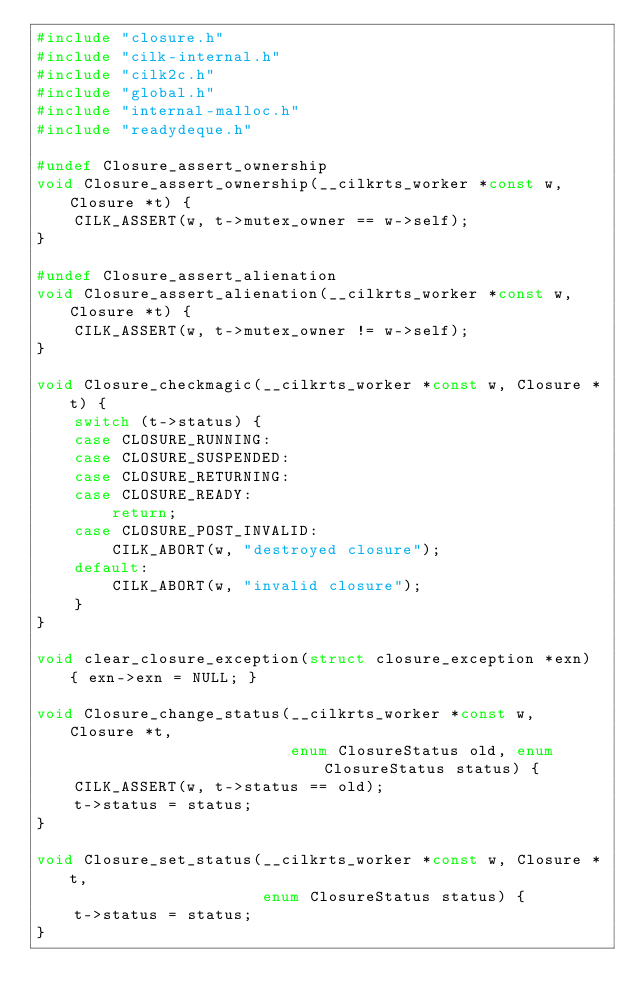Convert code to text. <code><loc_0><loc_0><loc_500><loc_500><_C_>#include "closure.h"
#include "cilk-internal.h"
#include "cilk2c.h"
#include "global.h"
#include "internal-malloc.h"
#include "readydeque.h"

#undef Closure_assert_ownership
void Closure_assert_ownership(__cilkrts_worker *const w, Closure *t) {
    CILK_ASSERT(w, t->mutex_owner == w->self);
}

#undef Closure_assert_alienation
void Closure_assert_alienation(__cilkrts_worker *const w, Closure *t) {
    CILK_ASSERT(w, t->mutex_owner != w->self);
}

void Closure_checkmagic(__cilkrts_worker *const w, Closure *t) {
    switch (t->status) {
    case CLOSURE_RUNNING:
    case CLOSURE_SUSPENDED:
    case CLOSURE_RETURNING:
    case CLOSURE_READY:
        return;
    case CLOSURE_POST_INVALID:
        CILK_ABORT(w, "destroyed closure");
    default:
        CILK_ABORT(w, "invalid closure");
    }
}

void clear_closure_exception(struct closure_exception *exn) { exn->exn = NULL; }

void Closure_change_status(__cilkrts_worker *const w, Closure *t,
                           enum ClosureStatus old, enum ClosureStatus status) {
    CILK_ASSERT(w, t->status == old);
    t->status = status;
}

void Closure_set_status(__cilkrts_worker *const w, Closure *t,
                        enum ClosureStatus status) {
    t->status = status;
}
</code> 